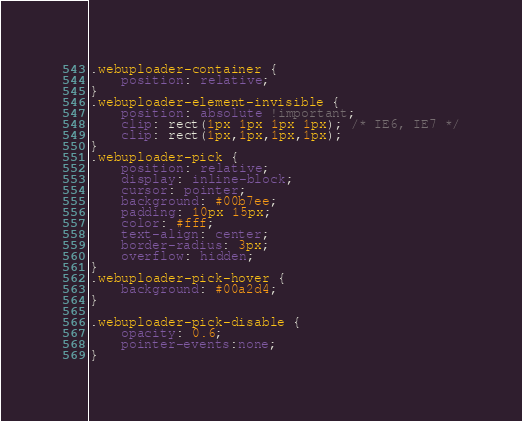Convert code to text. <code><loc_0><loc_0><loc_500><loc_500><_CSS_>.webuploader-container {
	position: relative;
}
.webuploader-element-invisible {
	position: absolute !important;
	clip: rect(1px 1px 1px 1px); /* IE6, IE7 */
    clip: rect(1px,1px,1px,1px);
}
.webuploader-pick {
	position: relative;
	display: inline-block;
	cursor: pointer;
	background: #00b7ee;
	padding: 10px 15px;
	color: #fff;
	text-align: center;
	border-radius: 3px;
	overflow: hidden;
}
.webuploader-pick-hover {
	background: #00a2d4;
}

.webuploader-pick-disable {
	opacity: 0.6;
	pointer-events:none;
}



</code> 